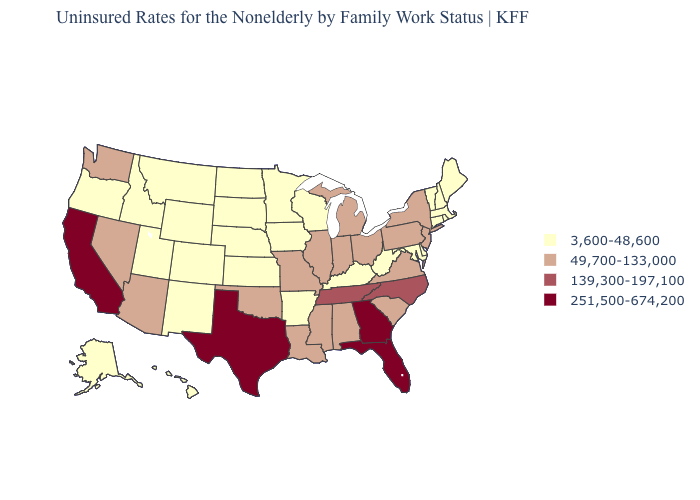Among the states that border Vermont , does New York have the lowest value?
Give a very brief answer. No. Which states have the lowest value in the USA?
Quick response, please. Alaska, Arkansas, Colorado, Connecticut, Delaware, Hawaii, Idaho, Iowa, Kansas, Kentucky, Maine, Maryland, Massachusetts, Minnesota, Montana, Nebraska, New Hampshire, New Mexico, North Dakota, Oregon, Rhode Island, South Dakota, Utah, Vermont, West Virginia, Wisconsin, Wyoming. Name the states that have a value in the range 251,500-674,200?
Keep it brief. California, Florida, Georgia, Texas. Which states have the lowest value in the USA?
Keep it brief. Alaska, Arkansas, Colorado, Connecticut, Delaware, Hawaii, Idaho, Iowa, Kansas, Kentucky, Maine, Maryland, Massachusetts, Minnesota, Montana, Nebraska, New Hampshire, New Mexico, North Dakota, Oregon, Rhode Island, South Dakota, Utah, Vermont, West Virginia, Wisconsin, Wyoming. Does the map have missing data?
Concise answer only. No. Among the states that border Nevada , which have the lowest value?
Quick response, please. Idaho, Oregon, Utah. Which states have the highest value in the USA?
Be succinct. California, Florida, Georgia, Texas. Does the map have missing data?
Keep it brief. No. How many symbols are there in the legend?
Quick response, please. 4. Name the states that have a value in the range 251,500-674,200?
Keep it brief. California, Florida, Georgia, Texas. What is the lowest value in states that border Idaho?
Short answer required. 3,600-48,600. Which states have the lowest value in the USA?
Be succinct. Alaska, Arkansas, Colorado, Connecticut, Delaware, Hawaii, Idaho, Iowa, Kansas, Kentucky, Maine, Maryland, Massachusetts, Minnesota, Montana, Nebraska, New Hampshire, New Mexico, North Dakota, Oregon, Rhode Island, South Dakota, Utah, Vermont, West Virginia, Wisconsin, Wyoming. Name the states that have a value in the range 3,600-48,600?
Answer briefly. Alaska, Arkansas, Colorado, Connecticut, Delaware, Hawaii, Idaho, Iowa, Kansas, Kentucky, Maine, Maryland, Massachusetts, Minnesota, Montana, Nebraska, New Hampshire, New Mexico, North Dakota, Oregon, Rhode Island, South Dakota, Utah, Vermont, West Virginia, Wisconsin, Wyoming. What is the highest value in the USA?
Quick response, please. 251,500-674,200. What is the value of New Hampshire?
Write a very short answer. 3,600-48,600. 